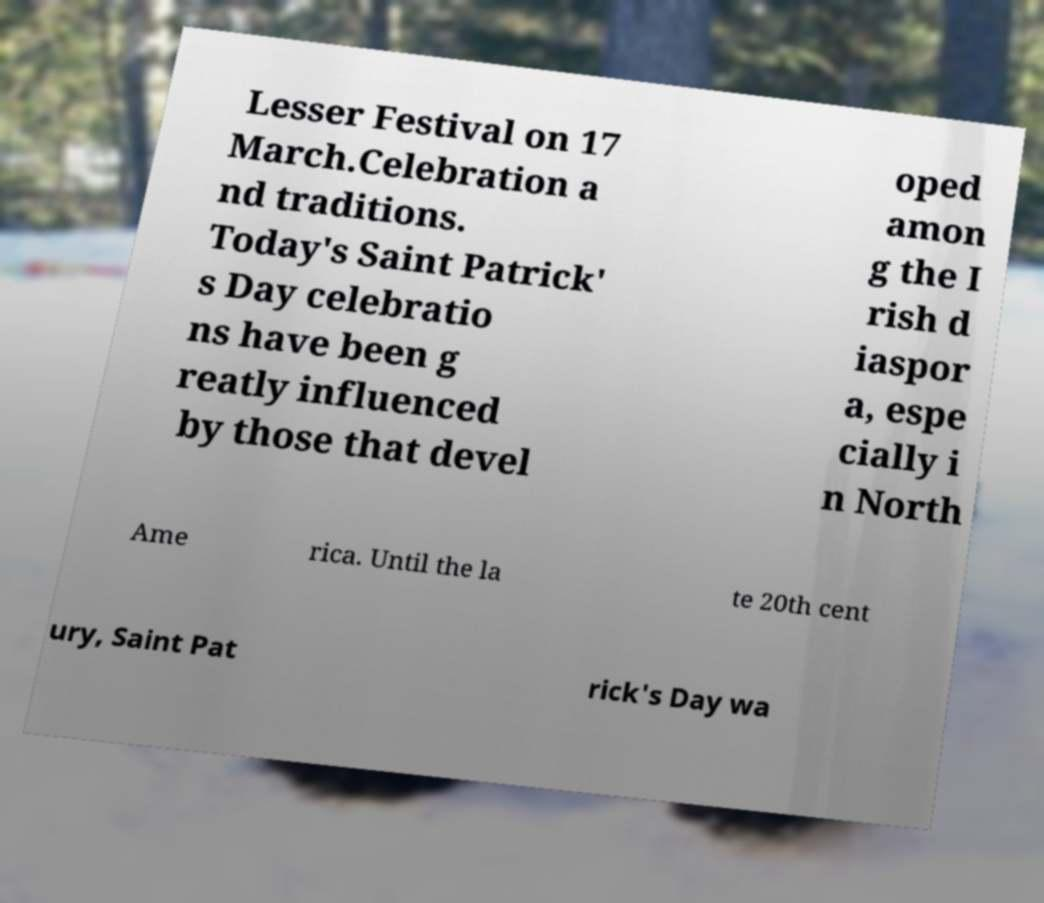Could you assist in decoding the text presented in this image and type it out clearly? Lesser Festival on 17 March.Celebration a nd traditions. Today's Saint Patrick' s Day celebratio ns have been g reatly influenced by those that devel oped amon g the I rish d iaspor a, espe cially i n North Ame rica. Until the la te 20th cent ury, Saint Pat rick's Day wa 